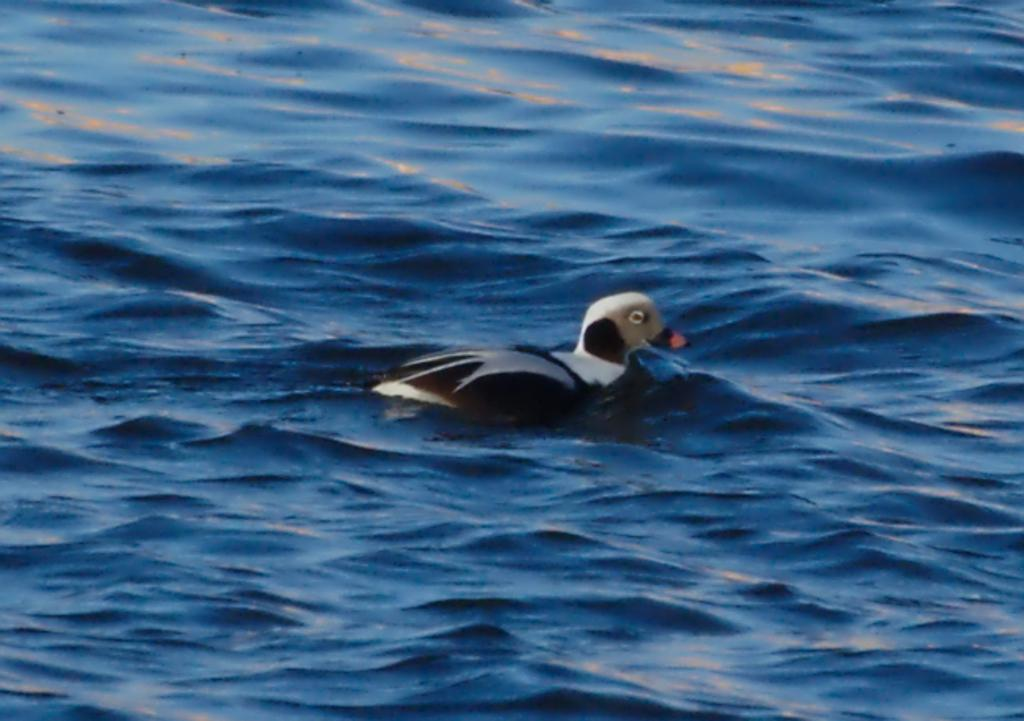What is the primary element visible in the image? There is water in the image. What type of animal can be seen in the image? There is a brown and white colored bird in the image. Where is the bird located in relation to the water? The bird is on the water. What type of prose is being recited by the bird in the image? There is no indication in the image that the bird is reciting any prose. How does the bottle support the bird in the image? There is no bottle present in the image, so it cannot support the bird. 